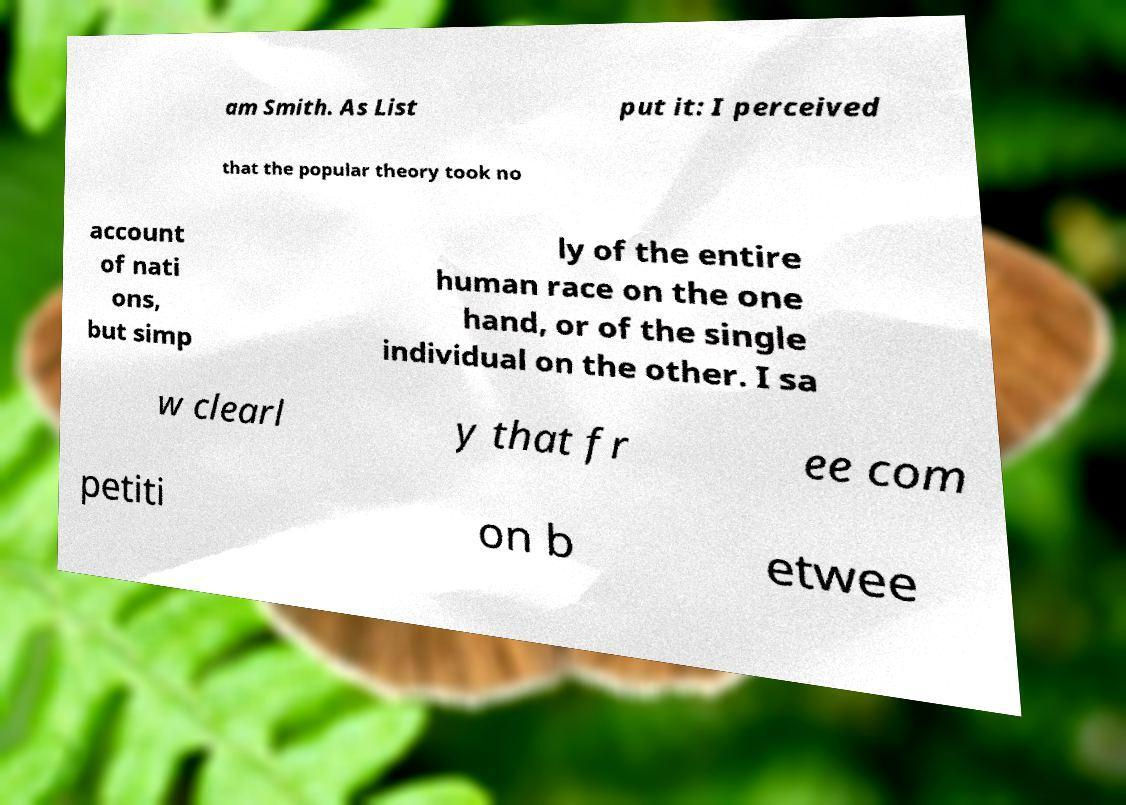Please identify and transcribe the text found in this image. am Smith. As List put it: I perceived that the popular theory took no account of nati ons, but simp ly of the entire human race on the one hand, or of the single individual on the other. I sa w clearl y that fr ee com petiti on b etwee 